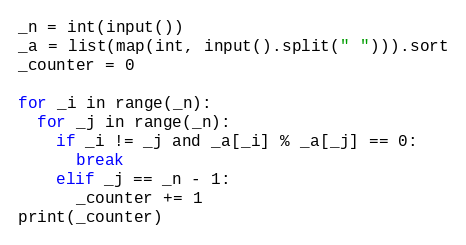<code> <loc_0><loc_0><loc_500><loc_500><_Python_>_n = int(input())
_a = list(map(int, input().split(" "))).sort
_counter = 0

for _i in range(_n):
  for _j in range(_n):
    if _i != _j and _a[_i] % _a[_j] == 0:
      break
    elif _j == _n - 1:
      _counter += 1
print(_counter)</code> 